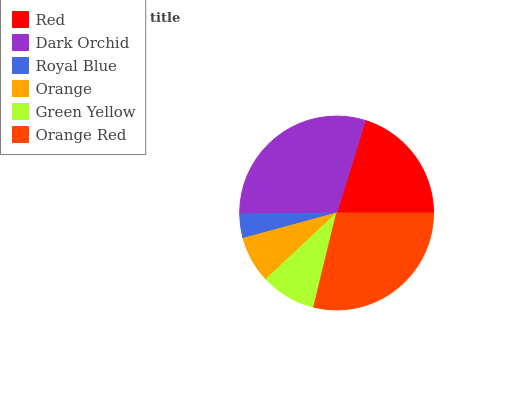Is Royal Blue the minimum?
Answer yes or no. Yes. Is Dark Orchid the maximum?
Answer yes or no. Yes. Is Dark Orchid the minimum?
Answer yes or no. No. Is Royal Blue the maximum?
Answer yes or no. No. Is Dark Orchid greater than Royal Blue?
Answer yes or no. Yes. Is Royal Blue less than Dark Orchid?
Answer yes or no. Yes. Is Royal Blue greater than Dark Orchid?
Answer yes or no. No. Is Dark Orchid less than Royal Blue?
Answer yes or no. No. Is Red the high median?
Answer yes or no. Yes. Is Green Yellow the low median?
Answer yes or no. Yes. Is Royal Blue the high median?
Answer yes or no. No. Is Red the low median?
Answer yes or no. No. 